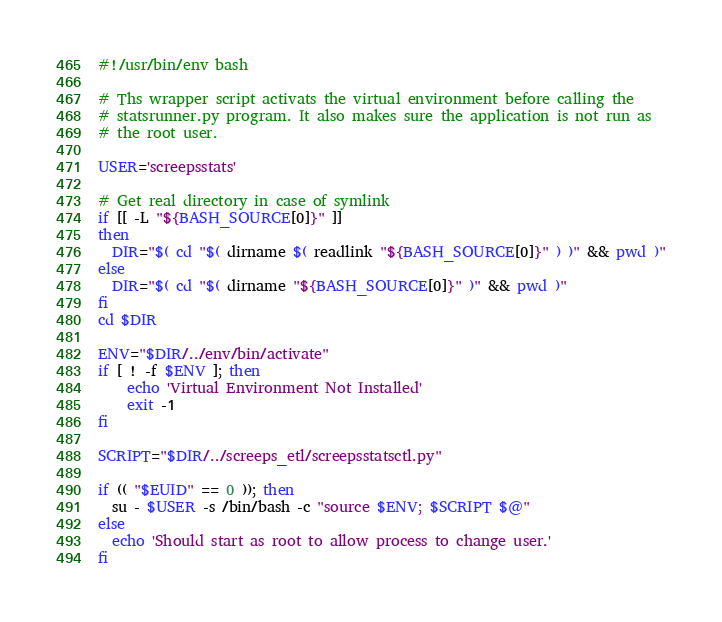<code> <loc_0><loc_0><loc_500><loc_500><_Bash_>#!/usr/bin/env bash

# Ths wrapper script activats the virtual environment before calling the
# statsrunner.py program. It also makes sure the application is not run as
# the root user.

USER='screepsstats'

# Get real directory in case of symlink
if [[ -L "${BASH_SOURCE[0]}" ]]
then
  DIR="$( cd "$( dirname $( readlink "${BASH_SOURCE[0]}" ) )" && pwd )"
else
  DIR="$( cd "$( dirname "${BASH_SOURCE[0]}" )" && pwd )"
fi
cd $DIR

ENV="$DIR/../env/bin/activate"
if [ ! -f $ENV ]; then
    echo 'Virtual Environment Not Installed'
    exit -1
fi

SCRIPT="$DIR/../screeps_etl/screepsstatsctl.py"

if (( "$EUID" == 0 )); then
  su - $USER -s /bin/bash -c "source $ENV; $SCRIPT $@"
else
  echo 'Should start as root to allow process to change user.'
fi
</code> 